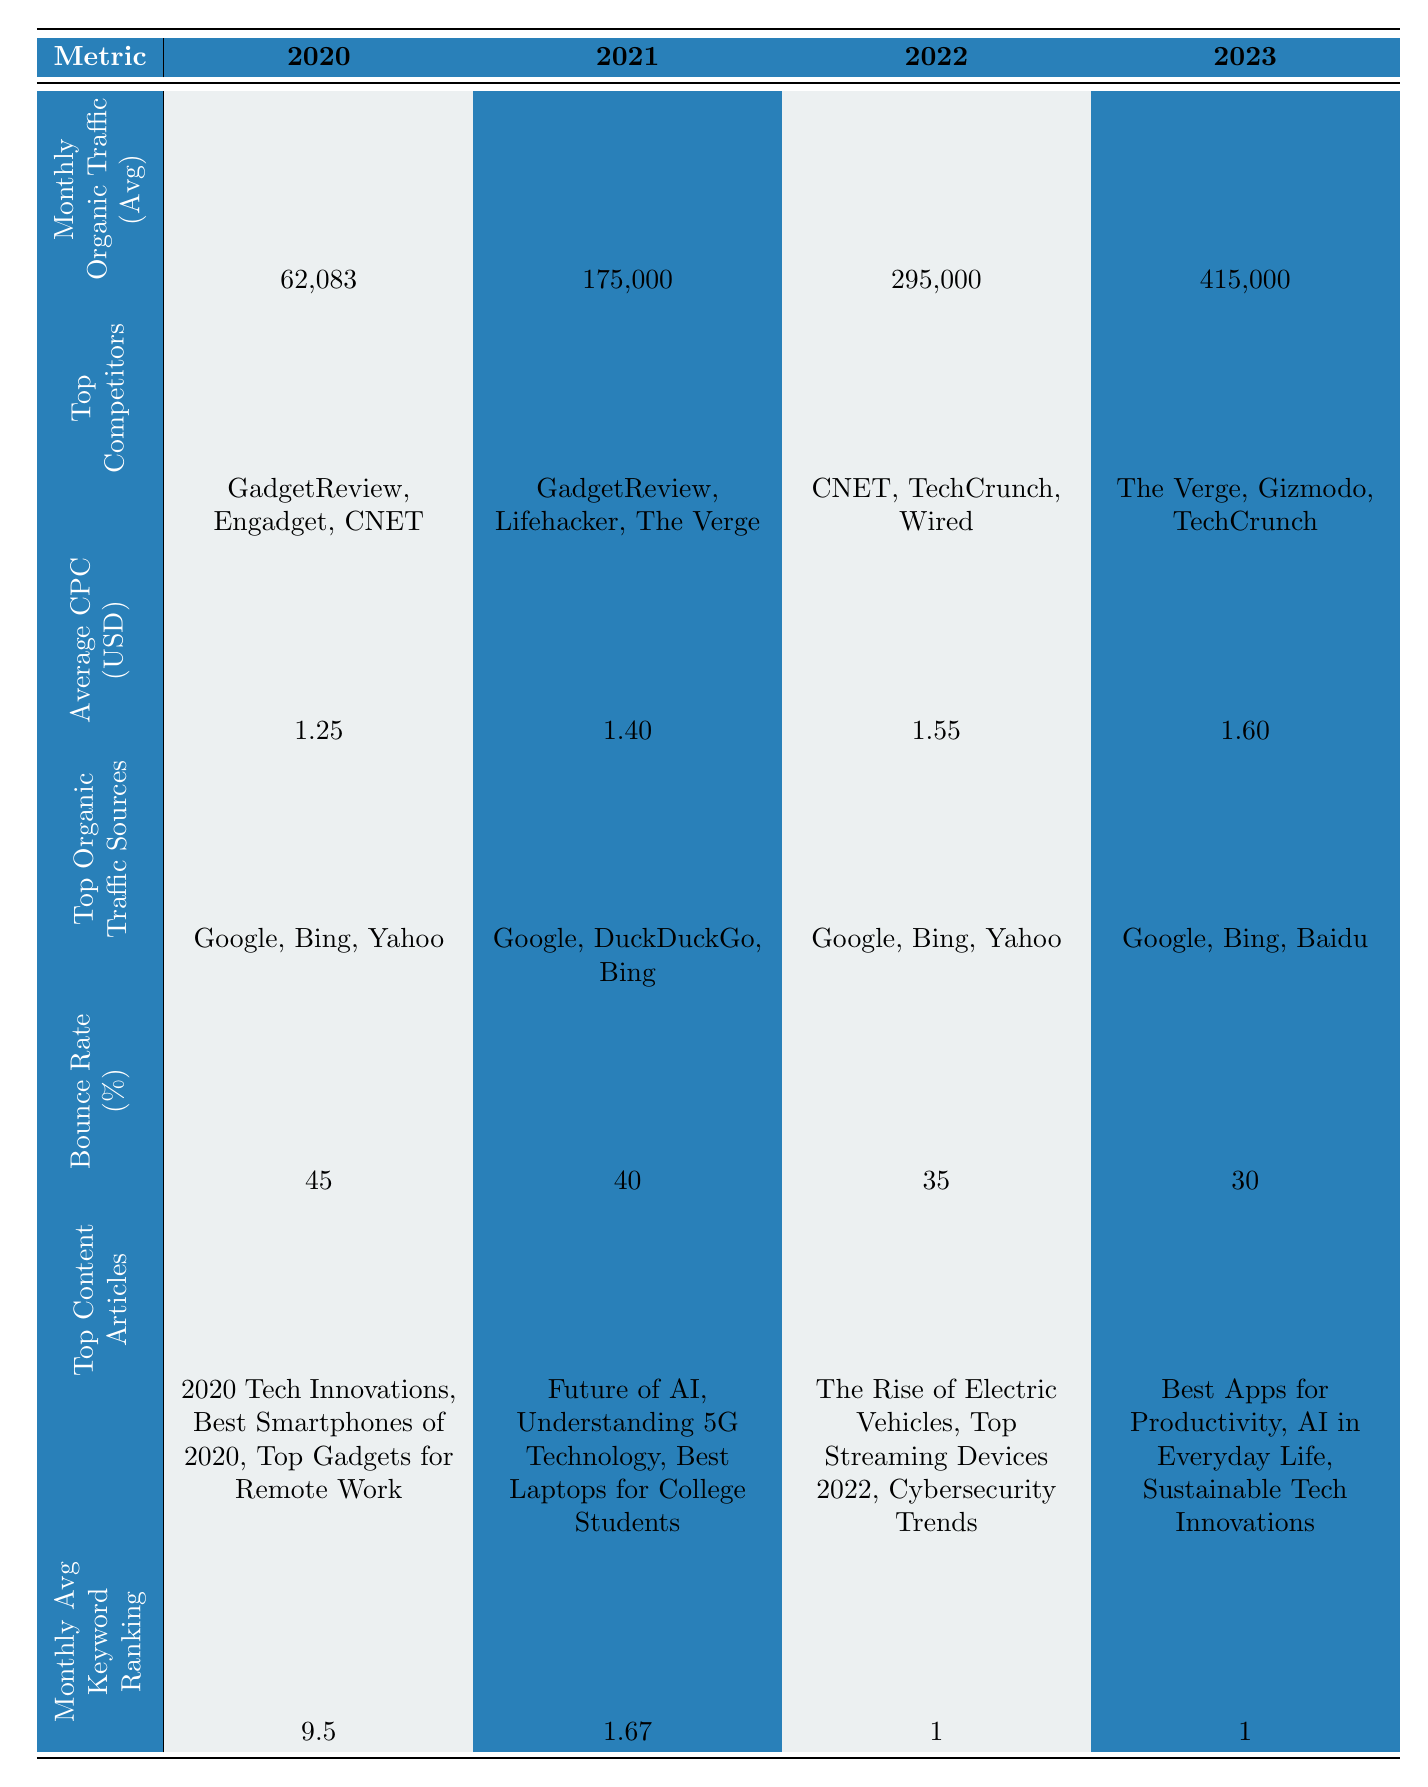What was the average monthly organic traffic for 2021? The monthly organic traffic for 2021 is provided directly in the table. The average is found by adding the values for each month (120000 + 130000 + 140000 + 150000 + 160000 + 170000 + 180000 + 190000 + 200000 + 210000 + 220000 + 230000) and then dividing by 12, which gives 175,000.
Answer: 175,000 Which year had the highest average monthly organic traffic? By comparing the average monthly organic traffic values listed for each year, 2023 has the highest value at 415,000, while the others are lower.
Answer: 2023 What is the average CPC for the years 2020 and 2021? The average CPC for 2020 is 1.25 and for 2021 is 1.40. To find the average, we add these two values (1.25 + 1.40) = 2.65 and divide by 2, which yields 1.325.
Answer: 1.325 Was the bounce rate lower in 2022 compared to 2021? Looking at the bounce rates for both years, 2021 has a bounce rate of 40% and 2022 has 35%. Since 35% is lower than 40%, the statement is true.
Answer: Yes List the top organic traffic sources in 2020. The table specifies the top organic traffic sources for 2020 as Google, Bing, and Yahoo, which is a direct retrieval of the data shown.
Answer: Google, Bing, Yahoo How much did the average monthly organic traffic increase from 2020 to 2023? The average monthly organic traffic for 2020 is 62,083 and for 2023 is 415,000. Subtracting the two values (415,000 - 62,083) gives an increase of 352,917.
Answer: 352,917 Which competitors were present in 2021 but not in 2020? The top competitors in 2021 are GadgetReview, Lifehacker, and The Verge. Comparing this with 2020’s competitors (GadgetReview, Engadget, CNET), we see that Lifehacker and The Verge were not present in 2020.
Answer: Lifehacker, The Verge Was there a change in the top content articles from 2020 to 2023? Yes, by comparing the top articles listed for 2020 and 2023, we see entirely different titles: "2020 Tech Innovations" vs. "Best Apps for Productivity," indicating a change.
Answer: Yes What is the trend of average keyword ranking from 2020 to 2023? The monthly average keyword ranking decreased from 9.5 in 2020 to 1 in 2022 and 2023, indicating an improvement in ranking over these years.
Answer: Improvement How did the average bounce rate change from 2020 to 2023? The average bounce rate decreased from 45% in 2020 to 30% in 2023. This indicates that user engagement improved as the rate went down.
Answer: Decreased 